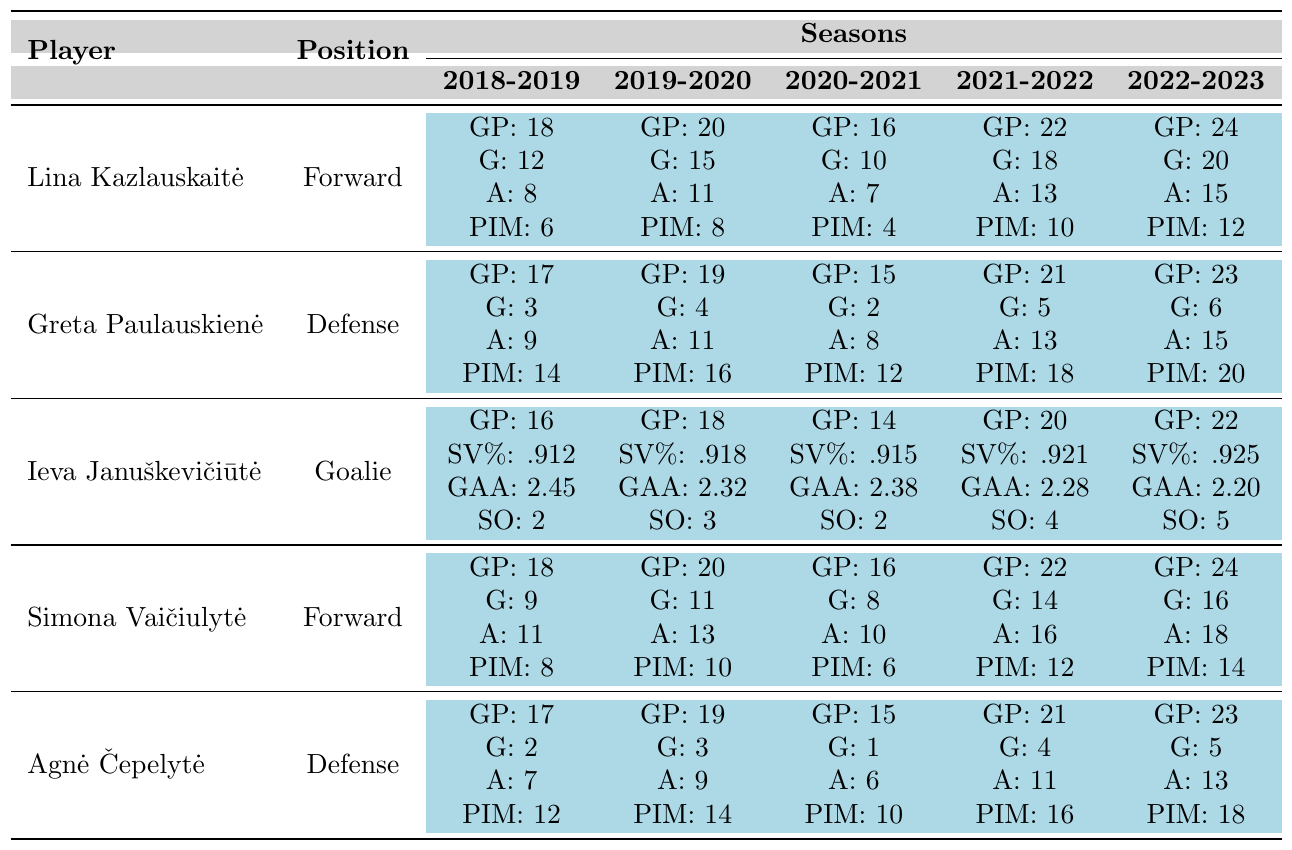What is the total number of goals scored by Lina Kazlauskaitė over the five seasons? To find the total goals, add Lina's goals from each season: 12 (2018-2019) + 15 (2019-2020) + 10 (2020-2021) + 18 (2021-2022) + 20 (2022-2023) = 75.
Answer: 75 Which player had the highest save percentage in the 2022-2023 season? Looking at the 2022-2023 season data, Ieva Januškevičiūtė had a save percentage of 0.925, which was the highest among all players.
Answer: Ieva Januškevičiūtė How many assists did Greta Paulauskienė record in total over the five seasons? The total assists for Greta are 9 (2018-2019) + 11 (2019-2020) + 8 (2020-2021) + 13 (2021-2022) + 15 (2022-2023) = 56.
Answer: 56 Did any player score goals in the 2020-2021 season without any assists? Checking the 2020-2021 season, Agnė Čepelytė scored 1 goal with 6 assists, but no other player scored with 0 assists. Thus, the answer is no.
Answer: No What was Simona Vaičiulytė's average number of penalty minutes across the five seasons? The penalty minutes for Simona are: 8 (2018-2019), 10 (2019-2020), 6 (2020-2021), 12 (2021-2022), and 14 (2022-2023). The sum is 50, and averaging over 5 seasons gives 50/5 = 10.
Answer: 10 Which player had the most games played in the 2021-2022 season? In the 2021-2022 season, Lina Kazlauskaitė played 22 games, Simona Vaičiulytė also played 22, which was the highest compared to others.
Answer: Lina Kazlauskaitė and Simona Vaičiulytė What is the difference in goals scored by Agnė Čepelytė from her best season to her worst season? Agnė's best year was 2022-2023 with 5 goals and her worst was 2020-2021 with 1 goal. The difference is 5 - 1 = 4.
Answer: 4 In which season did Ieva Januškevičiūtė achieve her best goals against average? The goals against average is lowest in the 2022-2023 season at 2.20, which is her best performance.
Answer: 2022-2023 How many total games did the forwards play over the five seasons? Adding the games played by forwards: Lina Kazlauskaitė (18+20+16+22+24) = 100 and Simona Vaičiulytė (18+20+16+22+24) = 100. Total = 100 + 100 = 200.
Answer: 200 Which position had the highest total number of penalty minutes across all seasons and what was that total? Adding penalty minutes: For Defenders, Greta has 14+16+12+18+20 = 80 and Agnė has 12+14+10+16+18 = 70. Total for Defense is 80 + 70 = 150. Forwards total (Lina and Simona) is 6+8+4+10+12 + 8+10+6+12+14 = 88. Since 150 > 88, Defense had the highest with 150.
Answer: Defense, 150 